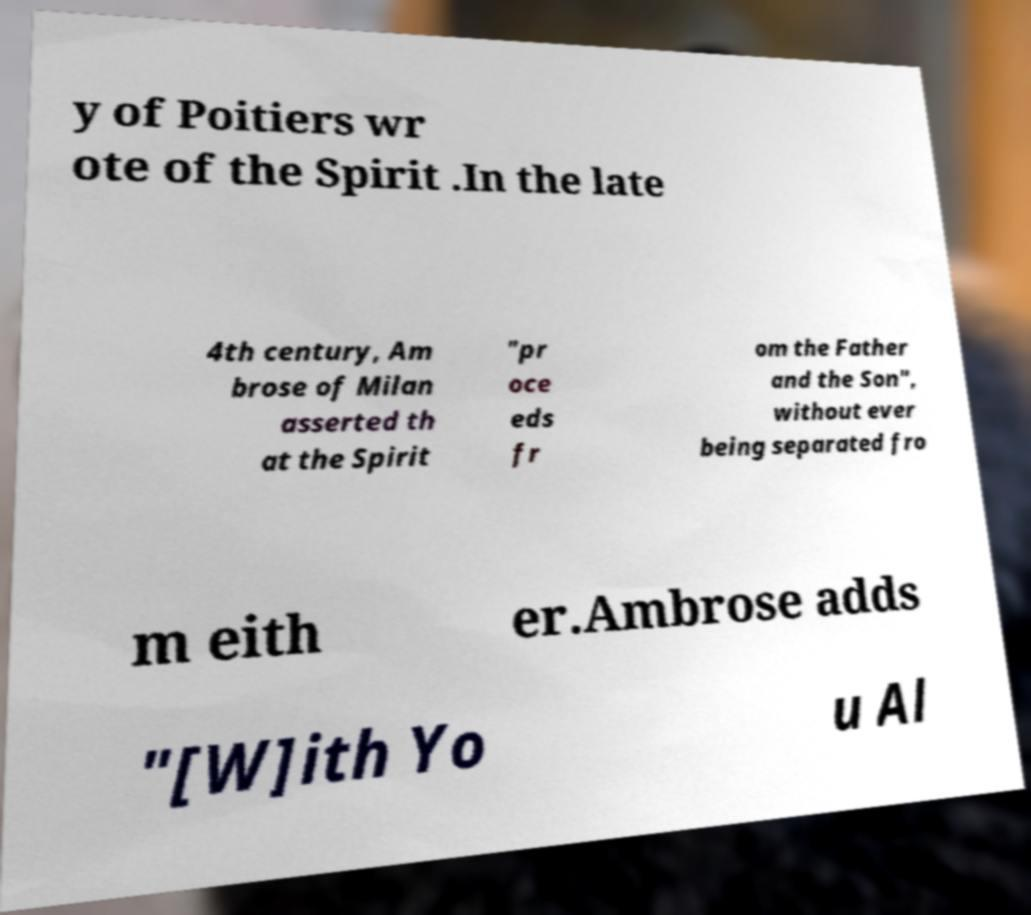There's text embedded in this image that I need extracted. Can you transcribe it verbatim? y of Poitiers wr ote of the Spirit .In the late 4th century, Am brose of Milan asserted th at the Spirit "pr oce eds fr om the Father and the Son", without ever being separated fro m eith er.Ambrose adds "[W]ith Yo u Al 